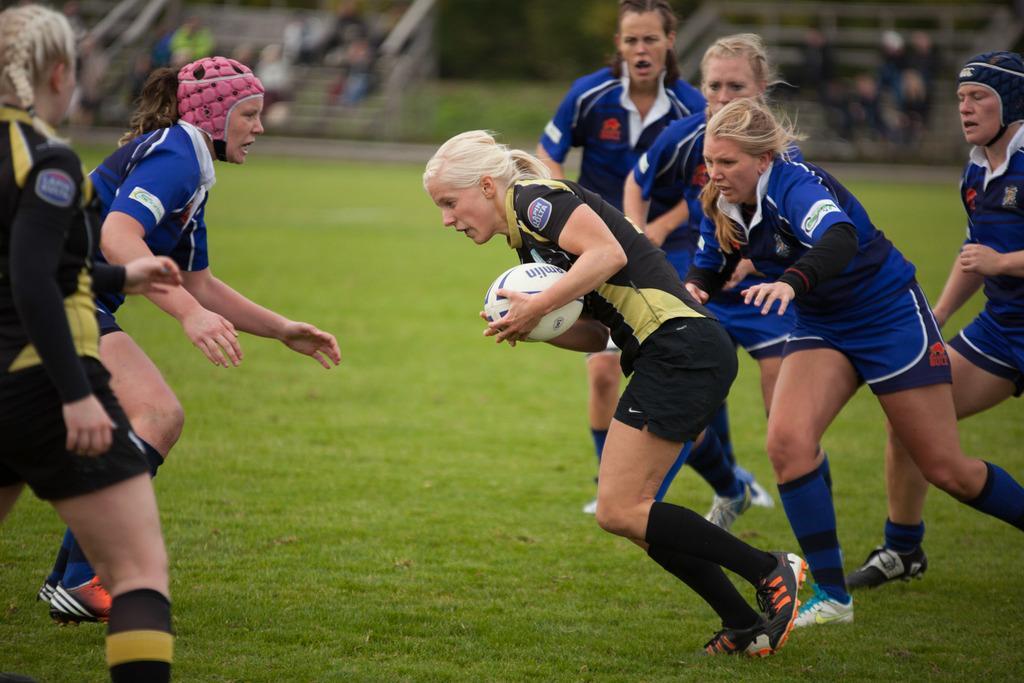How would you summarize this image in a sentence or two? In this image there are female rugby players who are playing the rugby. There is a woman in the middle who is holding the ball and running. In the background there are few people sitting in the stands. 